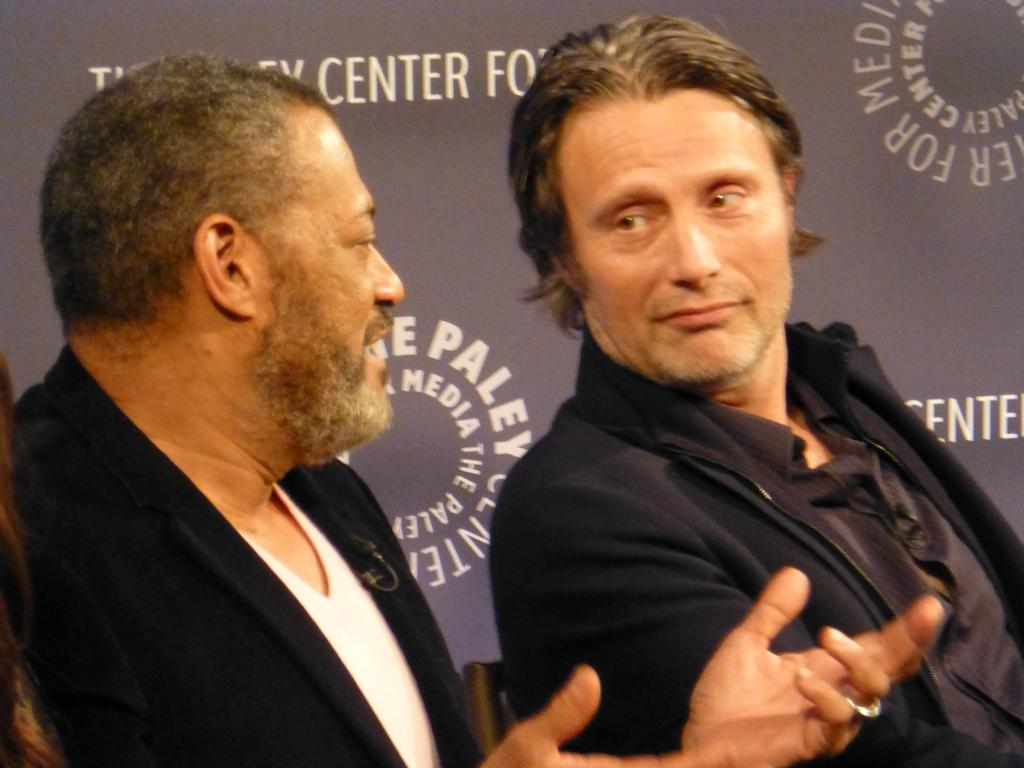How many people are in the image? There are two people in the image. What is one of the people doing? One of the people is sitting. What is the other person doing? The other person is talking. What can be seen in the background of the image? There is a banner in the background of the image. What type of pen is the writer using in the image? There is no writer or pen present in the image. How many bags can be seen in the image? There are no bags visible in the image. 